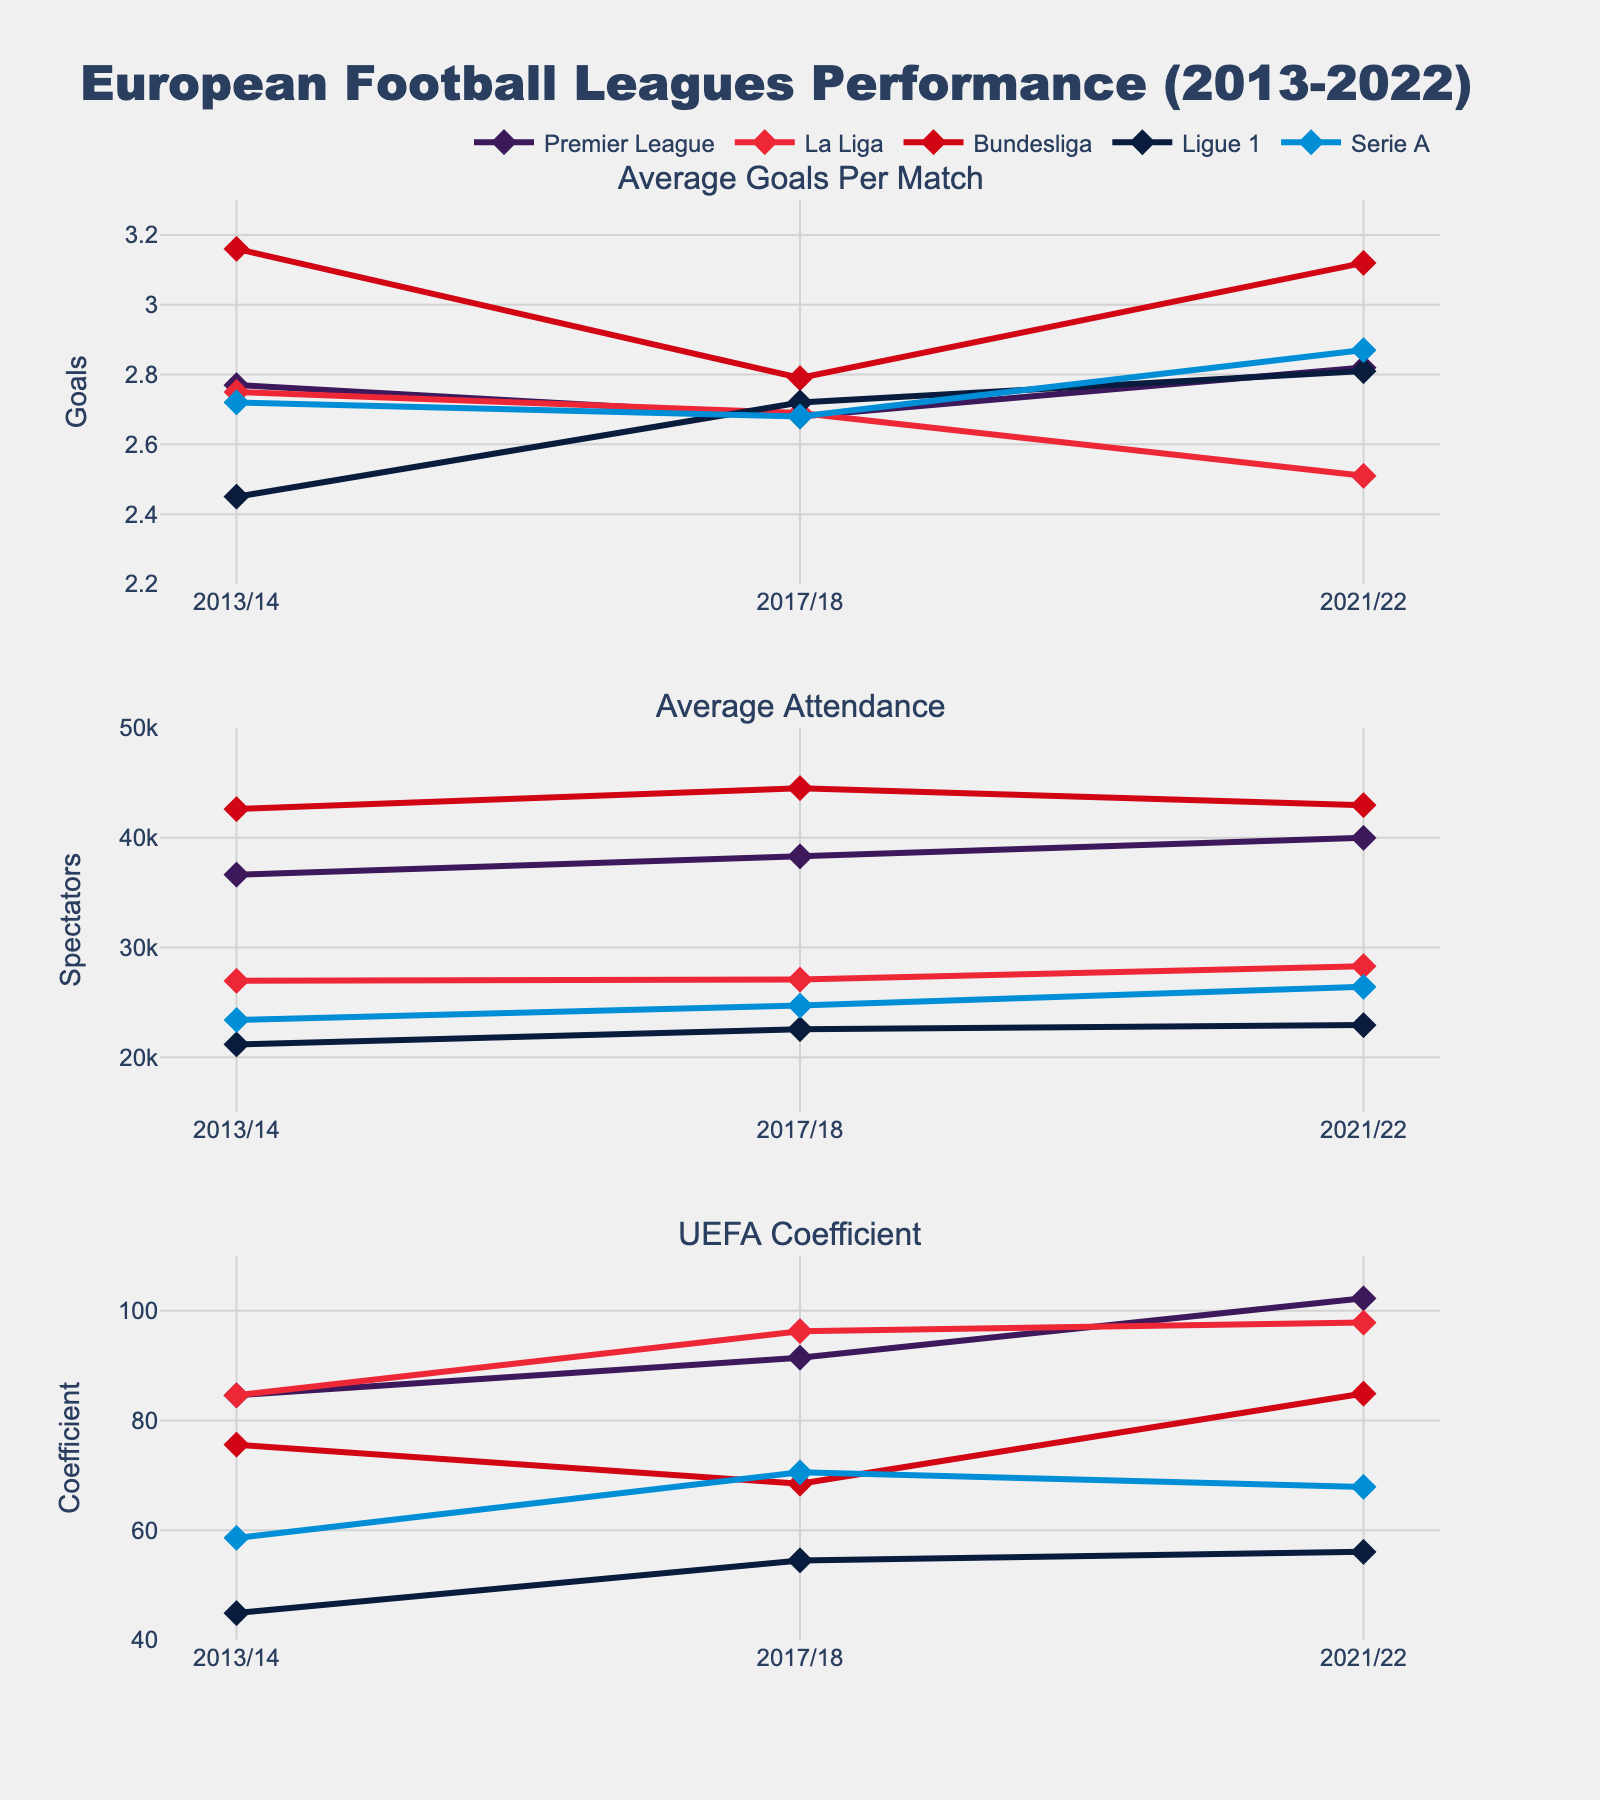What's the title of the figure? The title is located at the top center of the figure. It helps identify the main purpose or subject of the data shown. In this case, the title is "Educational Attainment Rates by Race and Ethnicity (1970-2020)".
Answer: Educational Attainment Rates by Race and Ethnicity (1970-2020) How many subplots are in the figure, and what races do they represent? The figure employs subplots, a practical method to present multiple aspects of a dataset concurrently.  There are 4 subplots, each representing a different race: White, Black, Hispanic, and Asian.
Answer: 4 subplots, representing White, Black, Hispanic, and Asian What is the general trend observed for the educational attainment rate of the Black population from 1970 to 2020? Observing the subplot for the Black population shows a consistent upward trend. The rate starts at approximately 31.4% in 1970 and increases steadily up to about 87.9% in 2020.
Answer: Increasing trend Which race had the highest educational attainment rate in 1970 and what was the rate? The 1970 point on the x-axis needs to be checked for each subplot. The highest value is in the Asian population's subplot, with a rate of approximately 68.5%.
Answer: Asian, 68.5% By how many percentage points did the educational attainment rate for the Hispanic population increase from 1970 to 2020? First, note the values for the Hispanic population in 1970 (32.1%) and 2020 (71.8%). The increase is found by subtracting the 1970 value from the 2020 value: 71.8% - 32.1% = 39.7%.
Answer: 39.7 percentage points Which race had the least increase in educational attainment rate over the 50-year period? Calculate the difference in rates from 1970 to 2020 for each race and compare them. Whites increased by (90.1 - 54.5) 35.6%, Blacks by (87.9 - 31.4) 56.5%, Hispanics by (71.8 - 32.1) 39.7%, and Asians by (91.3 - 68.5) 22.8%. Asians had the smallest increase.
Answer: Asian In what decade did the Black population see the most significant increase in educational attainment? Compare the increases between each consecutive decade for the Black population: 1970-1980 (51.4 - 31.4 = 20%), 1980-1990 (63.1 - 51.4 = 11.7%), 1990-2000 (72.3 - 63.1 = 9.2%), 2000-2010 (84.2 - 72.3 = 11.9%), and 2010-2020 (87.9 - 84.2 = 3.7%). The most significant increase occurred from 1970 to 1980.
Answer: 1970-1980 Compare the educational attainment rate trendlines for the White and Hispanic populations. Which population seemed to experience a steadier, more consistent increase? By comparing both subplots visually over time, both lines rise, but the White population's line is smoother and more consistent, indicating a steadier improvement compared to the Hispanic population, which shows more variation.
Answer: White population Among the subplots, which race had the lowest educational attainment rate in 2020? By examining the value at the 2020 point on the x-axis for each subplot, the Hispanic population had the lowest rate at approximately 71.8%.
Answer: Hispanic, 71.8% Which decade did the Asian population cross the 80% mark in educational attainment? Examine the Asian population’s subplot to see where the line crosses the 80% y-axis mark. This happens between 1980 and 1990.
Answer: 1980-1990 